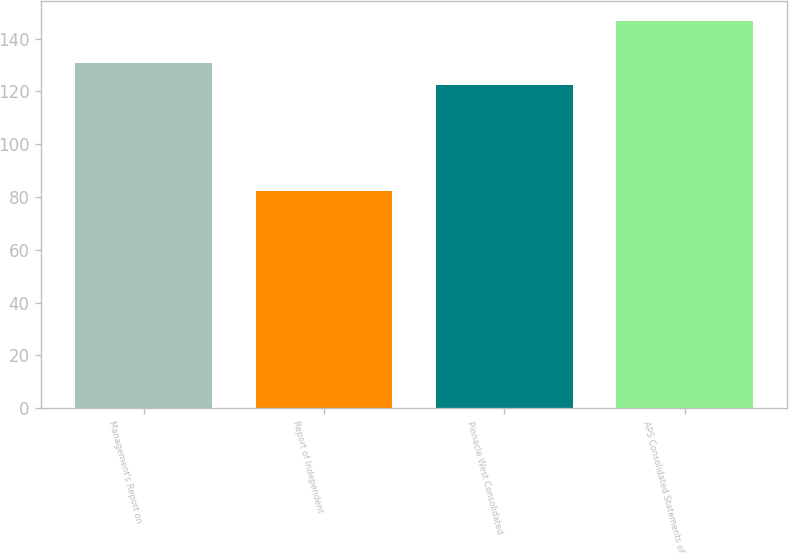Convert chart. <chart><loc_0><loc_0><loc_500><loc_500><bar_chart><fcel>Management's Report on<fcel>Report of Independent<fcel>Pinnacle West Consolidated<fcel>APS Consolidated Statements of<nl><fcel>130.7<fcel>82.1<fcel>122.6<fcel>146.9<nl></chart> 